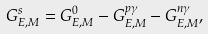Convert formula to latex. <formula><loc_0><loc_0><loc_500><loc_500>G _ { E , M } ^ { s } = G _ { E , M } ^ { 0 } - G _ { E , M } ^ { p \gamma } - G _ { E , M } ^ { n \gamma } ,</formula> 